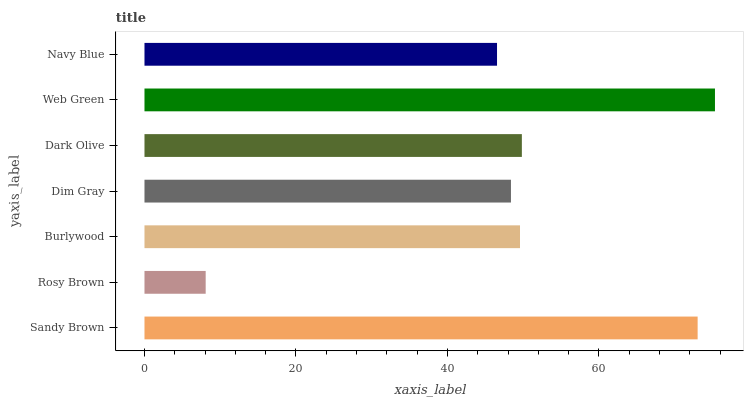Is Rosy Brown the minimum?
Answer yes or no. Yes. Is Web Green the maximum?
Answer yes or no. Yes. Is Burlywood the minimum?
Answer yes or no. No. Is Burlywood the maximum?
Answer yes or no. No. Is Burlywood greater than Rosy Brown?
Answer yes or no. Yes. Is Rosy Brown less than Burlywood?
Answer yes or no. Yes. Is Rosy Brown greater than Burlywood?
Answer yes or no. No. Is Burlywood less than Rosy Brown?
Answer yes or no. No. Is Burlywood the high median?
Answer yes or no. Yes. Is Burlywood the low median?
Answer yes or no. Yes. Is Dim Gray the high median?
Answer yes or no. No. Is Rosy Brown the low median?
Answer yes or no. No. 